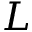<formula> <loc_0><loc_0><loc_500><loc_500>L</formula> 